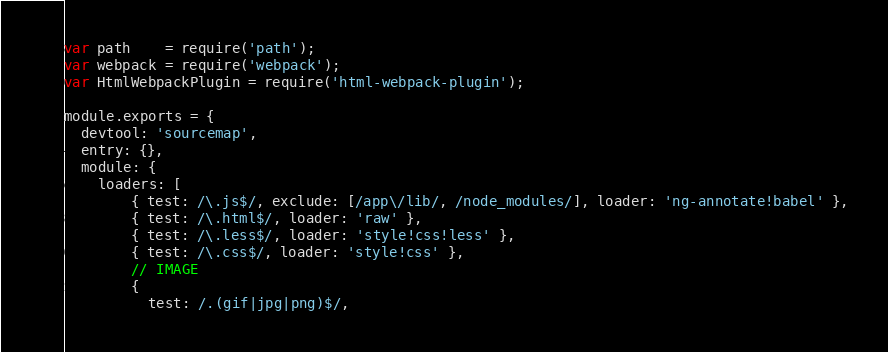<code> <loc_0><loc_0><loc_500><loc_500><_JavaScript_>var path    = require('path');
var webpack = require('webpack');
var HtmlWebpackPlugin = require('html-webpack-plugin');

module.exports = {
  devtool: 'sourcemap',
  entry: {},
  module: {
    loaders: [
        { test: /\.js$/, exclude: [/app\/lib/, /node_modules/], loader: 'ng-annotate!babel' },
        { test: /\.html$/, loader: 'raw' },
        { test: /\.less$/, loader: 'style!css!less' },
        { test: /\.css$/, loader: 'style!css' },
        // IMAGE
        {
          test: /.(gif|jpg|png)$/,</code> 